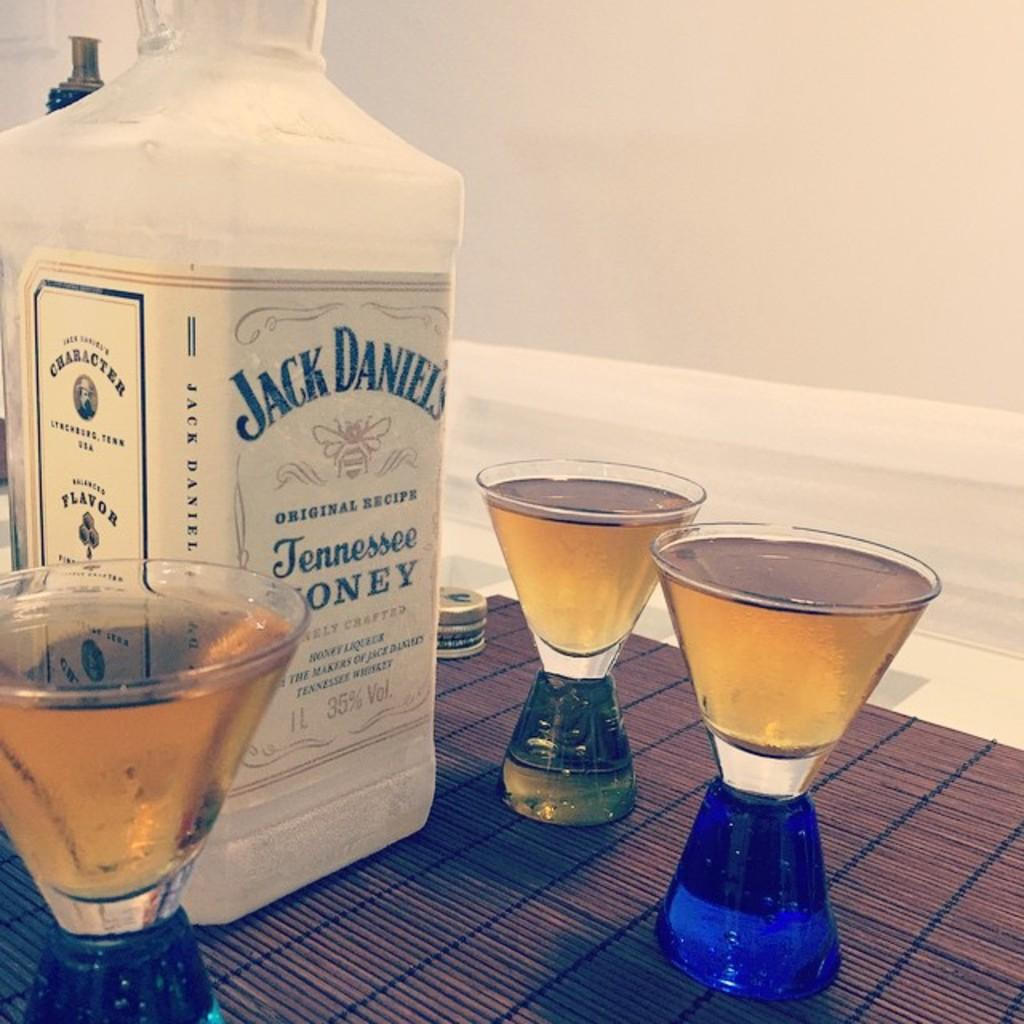<image>
Summarize the visual content of the image. A bottle of Jack Daniel's sits on a table with three drinking glasses full of liquid. 